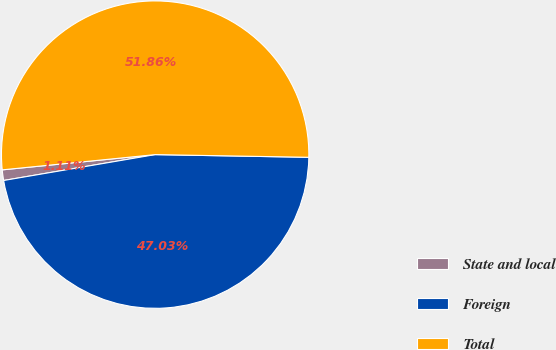Convert chart. <chart><loc_0><loc_0><loc_500><loc_500><pie_chart><fcel>State and local<fcel>Foreign<fcel>Total<nl><fcel>1.11%<fcel>47.03%<fcel>51.86%<nl></chart> 